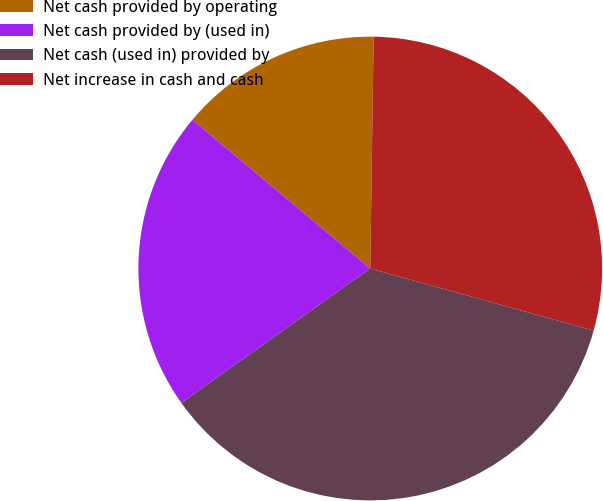Convert chart to OTSL. <chart><loc_0><loc_0><loc_500><loc_500><pie_chart><fcel>Net cash provided by operating<fcel>Net cash provided by (used in)<fcel>Net cash (used in) provided by<fcel>Net increase in cash and cash<nl><fcel>14.15%<fcel>20.92%<fcel>35.85%<fcel>29.08%<nl></chart> 